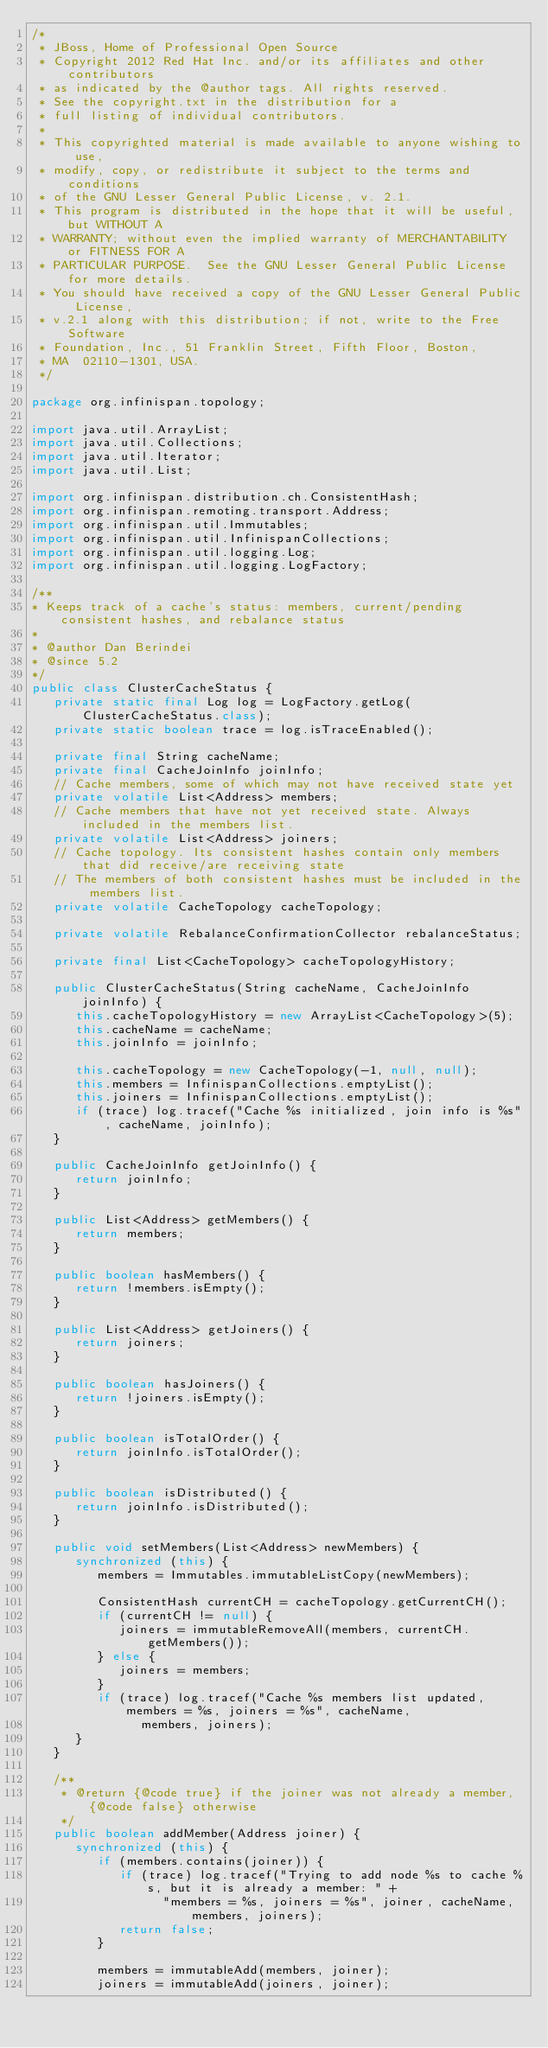Convert code to text. <code><loc_0><loc_0><loc_500><loc_500><_Java_>/*
 * JBoss, Home of Professional Open Source
 * Copyright 2012 Red Hat Inc. and/or its affiliates and other contributors
 * as indicated by the @author tags. All rights reserved.
 * See the copyright.txt in the distribution for a
 * full listing of individual contributors.
 *
 * This copyrighted material is made available to anyone wishing to use,
 * modify, copy, or redistribute it subject to the terms and conditions
 * of the GNU Lesser General Public License, v. 2.1.
 * This program is distributed in the hope that it will be useful, but WITHOUT A
 * WARRANTY; without even the implied warranty of MERCHANTABILITY or FITNESS FOR A
 * PARTICULAR PURPOSE.  See the GNU Lesser General Public License for more details.
 * You should have received a copy of the GNU Lesser General Public License,
 * v.2.1 along with this distribution; if not, write to the Free Software
 * Foundation, Inc., 51 Franklin Street, Fifth Floor, Boston,
 * MA  02110-1301, USA.
 */

package org.infinispan.topology;

import java.util.ArrayList;
import java.util.Collections;
import java.util.Iterator;
import java.util.List;

import org.infinispan.distribution.ch.ConsistentHash;
import org.infinispan.remoting.transport.Address;
import org.infinispan.util.Immutables;
import org.infinispan.util.InfinispanCollections;
import org.infinispan.util.logging.Log;
import org.infinispan.util.logging.LogFactory;

/**
* Keeps track of a cache's status: members, current/pending consistent hashes, and rebalance status
*
* @author Dan Berindei
* @since 5.2
*/
public class ClusterCacheStatus {
   private static final Log log = LogFactory.getLog(ClusterCacheStatus.class);
   private static boolean trace = log.isTraceEnabled();

   private final String cacheName;
   private final CacheJoinInfo joinInfo;
   // Cache members, some of which may not have received state yet
   private volatile List<Address> members;
   // Cache members that have not yet received state. Always included in the members list.
   private volatile List<Address> joiners;
   // Cache topology. Its consistent hashes contain only members that did receive/are receiving state
   // The members of both consistent hashes must be included in the members list.
   private volatile CacheTopology cacheTopology;

   private volatile RebalanceConfirmationCollector rebalanceStatus;

   private final List<CacheTopology> cacheTopologyHistory;

   public ClusterCacheStatus(String cacheName, CacheJoinInfo joinInfo) {
      this.cacheTopologyHistory = new ArrayList<CacheTopology>(5);
      this.cacheName = cacheName;
      this.joinInfo = joinInfo;

      this.cacheTopology = new CacheTopology(-1, null, null);
      this.members = InfinispanCollections.emptyList();
      this.joiners = InfinispanCollections.emptyList();
      if (trace) log.tracef("Cache %s initialized, join info is %s", cacheName, joinInfo);
   }

   public CacheJoinInfo getJoinInfo() {
      return joinInfo;
   }

   public List<Address> getMembers() {
      return members;
   }

   public boolean hasMembers() {
      return !members.isEmpty();
   }

   public List<Address> getJoiners() {
      return joiners;
   }

   public boolean hasJoiners() {
      return !joiners.isEmpty();
   }

   public boolean isTotalOrder() {
      return joinInfo.isTotalOrder();
   }

   public boolean isDistributed() {
      return joinInfo.isDistributed();
   }

   public void setMembers(List<Address> newMembers) {
      synchronized (this) {
         members = Immutables.immutableListCopy(newMembers);

         ConsistentHash currentCH = cacheTopology.getCurrentCH();
         if (currentCH != null) {
            joiners = immutableRemoveAll(members, currentCH.getMembers());
         } else {
            joiners = members;
         }
         if (trace) log.tracef("Cache %s members list updated, members = %s, joiners = %s", cacheName,
               members, joiners);
      }
   }

   /**
    * @return {@code true} if the joiner was not already a member, {@code false} otherwise
    */
   public boolean addMember(Address joiner) {
      synchronized (this) {
         if (members.contains(joiner)) {
            if (trace) log.tracef("Trying to add node %s to cache %s, but it is already a member: " +
                  "members = %s, joiners = %s", joiner, cacheName, members, joiners);
            return false;
         }

         members = immutableAdd(members, joiner);
         joiners = immutableAdd(joiners, joiner);</code> 